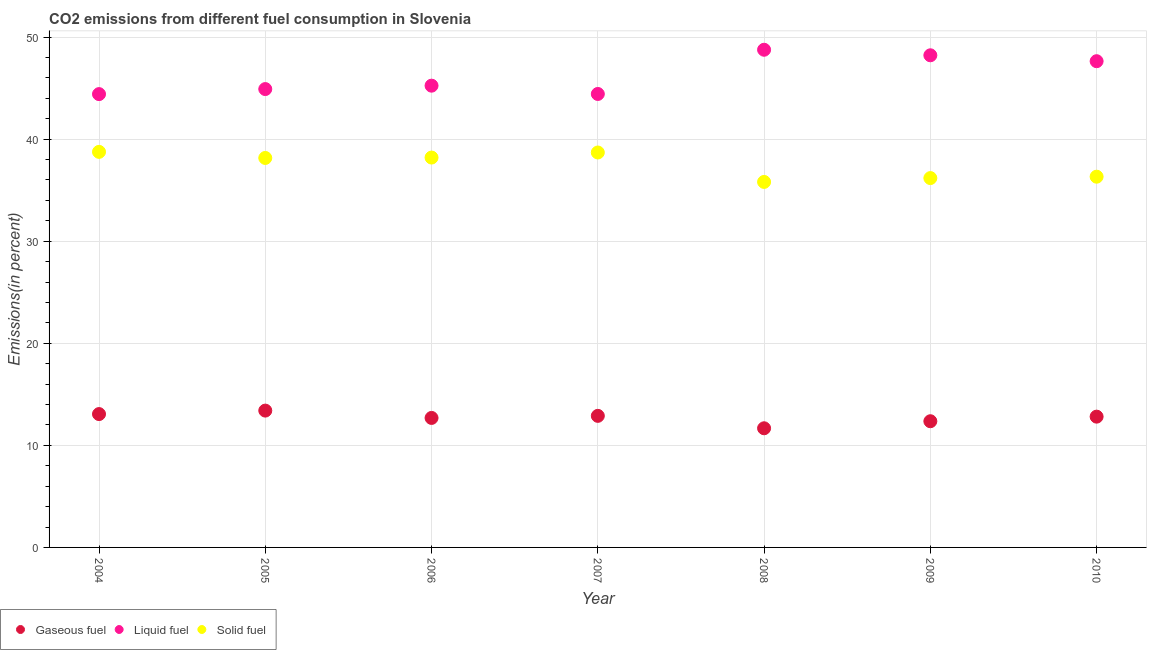How many different coloured dotlines are there?
Provide a short and direct response. 3. Is the number of dotlines equal to the number of legend labels?
Keep it short and to the point. Yes. What is the percentage of liquid fuel emission in 2010?
Offer a very short reply. 47.63. Across all years, what is the maximum percentage of solid fuel emission?
Give a very brief answer. 38.75. Across all years, what is the minimum percentage of solid fuel emission?
Make the answer very short. 35.81. What is the total percentage of gaseous fuel emission in the graph?
Keep it short and to the point. 88.89. What is the difference between the percentage of liquid fuel emission in 2006 and that in 2008?
Your answer should be very brief. -3.52. What is the difference between the percentage of liquid fuel emission in 2008 and the percentage of gaseous fuel emission in 2004?
Your answer should be very brief. 35.69. What is the average percentage of liquid fuel emission per year?
Ensure brevity in your answer.  46.23. In the year 2010, what is the difference between the percentage of solid fuel emission and percentage of gaseous fuel emission?
Ensure brevity in your answer.  23.51. What is the ratio of the percentage of gaseous fuel emission in 2009 to that in 2010?
Provide a short and direct response. 0.96. What is the difference between the highest and the second highest percentage of liquid fuel emission?
Offer a terse response. 0.54. What is the difference between the highest and the lowest percentage of solid fuel emission?
Your answer should be compact. 2.94. In how many years, is the percentage of solid fuel emission greater than the average percentage of solid fuel emission taken over all years?
Provide a short and direct response. 4. Is it the case that in every year, the sum of the percentage of gaseous fuel emission and percentage of liquid fuel emission is greater than the percentage of solid fuel emission?
Give a very brief answer. Yes. Is the percentage of liquid fuel emission strictly greater than the percentage of solid fuel emission over the years?
Your answer should be very brief. Yes. How many years are there in the graph?
Provide a succinct answer. 7. Are the values on the major ticks of Y-axis written in scientific E-notation?
Your answer should be very brief. No. Does the graph contain any zero values?
Provide a short and direct response. No. Where does the legend appear in the graph?
Ensure brevity in your answer.  Bottom left. How are the legend labels stacked?
Your answer should be compact. Horizontal. What is the title of the graph?
Provide a short and direct response. CO2 emissions from different fuel consumption in Slovenia. What is the label or title of the Y-axis?
Provide a succinct answer. Emissions(in percent). What is the Emissions(in percent) of Gaseous fuel in 2004?
Give a very brief answer. 13.06. What is the Emissions(in percent) of Liquid fuel in 2004?
Give a very brief answer. 44.41. What is the Emissions(in percent) in Solid fuel in 2004?
Your answer should be compact. 38.75. What is the Emissions(in percent) in Gaseous fuel in 2005?
Provide a short and direct response. 13.4. What is the Emissions(in percent) of Liquid fuel in 2005?
Offer a very short reply. 44.9. What is the Emissions(in percent) in Solid fuel in 2005?
Your response must be concise. 38.16. What is the Emissions(in percent) in Gaseous fuel in 2006?
Your response must be concise. 12.69. What is the Emissions(in percent) in Liquid fuel in 2006?
Keep it short and to the point. 45.24. What is the Emissions(in percent) of Solid fuel in 2006?
Your response must be concise. 38.19. What is the Emissions(in percent) in Gaseous fuel in 2007?
Keep it short and to the point. 12.89. What is the Emissions(in percent) in Liquid fuel in 2007?
Offer a very short reply. 44.42. What is the Emissions(in percent) of Solid fuel in 2007?
Your answer should be very brief. 38.69. What is the Emissions(in percent) in Gaseous fuel in 2008?
Your answer should be very brief. 11.67. What is the Emissions(in percent) in Liquid fuel in 2008?
Your response must be concise. 48.76. What is the Emissions(in percent) of Solid fuel in 2008?
Provide a succinct answer. 35.81. What is the Emissions(in percent) of Gaseous fuel in 2009?
Your response must be concise. 12.36. What is the Emissions(in percent) of Liquid fuel in 2009?
Make the answer very short. 48.21. What is the Emissions(in percent) of Solid fuel in 2009?
Your answer should be compact. 36.18. What is the Emissions(in percent) in Gaseous fuel in 2010?
Provide a succinct answer. 12.81. What is the Emissions(in percent) in Liquid fuel in 2010?
Offer a very short reply. 47.63. What is the Emissions(in percent) in Solid fuel in 2010?
Offer a very short reply. 36.32. Across all years, what is the maximum Emissions(in percent) of Gaseous fuel?
Give a very brief answer. 13.4. Across all years, what is the maximum Emissions(in percent) of Liquid fuel?
Offer a terse response. 48.76. Across all years, what is the maximum Emissions(in percent) in Solid fuel?
Your answer should be very brief. 38.75. Across all years, what is the minimum Emissions(in percent) in Gaseous fuel?
Give a very brief answer. 11.67. Across all years, what is the minimum Emissions(in percent) in Liquid fuel?
Give a very brief answer. 44.41. Across all years, what is the minimum Emissions(in percent) in Solid fuel?
Provide a short and direct response. 35.81. What is the total Emissions(in percent) of Gaseous fuel in the graph?
Your response must be concise. 88.89. What is the total Emissions(in percent) of Liquid fuel in the graph?
Your answer should be compact. 323.58. What is the total Emissions(in percent) in Solid fuel in the graph?
Keep it short and to the point. 262.1. What is the difference between the Emissions(in percent) of Gaseous fuel in 2004 and that in 2005?
Provide a short and direct response. -0.34. What is the difference between the Emissions(in percent) of Liquid fuel in 2004 and that in 2005?
Ensure brevity in your answer.  -0.49. What is the difference between the Emissions(in percent) in Solid fuel in 2004 and that in 2005?
Your answer should be compact. 0.6. What is the difference between the Emissions(in percent) in Gaseous fuel in 2004 and that in 2006?
Provide a succinct answer. 0.38. What is the difference between the Emissions(in percent) of Liquid fuel in 2004 and that in 2006?
Your answer should be compact. -0.83. What is the difference between the Emissions(in percent) in Solid fuel in 2004 and that in 2006?
Your answer should be compact. 0.56. What is the difference between the Emissions(in percent) in Gaseous fuel in 2004 and that in 2007?
Give a very brief answer. 0.18. What is the difference between the Emissions(in percent) of Liquid fuel in 2004 and that in 2007?
Provide a short and direct response. -0.01. What is the difference between the Emissions(in percent) of Solid fuel in 2004 and that in 2007?
Give a very brief answer. 0.06. What is the difference between the Emissions(in percent) of Gaseous fuel in 2004 and that in 2008?
Keep it short and to the point. 1.39. What is the difference between the Emissions(in percent) in Liquid fuel in 2004 and that in 2008?
Your response must be concise. -4.35. What is the difference between the Emissions(in percent) of Solid fuel in 2004 and that in 2008?
Your answer should be very brief. 2.94. What is the difference between the Emissions(in percent) in Gaseous fuel in 2004 and that in 2009?
Keep it short and to the point. 0.7. What is the difference between the Emissions(in percent) in Liquid fuel in 2004 and that in 2009?
Provide a succinct answer. -3.8. What is the difference between the Emissions(in percent) in Solid fuel in 2004 and that in 2009?
Give a very brief answer. 2.57. What is the difference between the Emissions(in percent) in Gaseous fuel in 2004 and that in 2010?
Make the answer very short. 0.25. What is the difference between the Emissions(in percent) of Liquid fuel in 2004 and that in 2010?
Your response must be concise. -3.22. What is the difference between the Emissions(in percent) in Solid fuel in 2004 and that in 2010?
Your response must be concise. 2.43. What is the difference between the Emissions(in percent) in Gaseous fuel in 2005 and that in 2006?
Offer a very short reply. 0.72. What is the difference between the Emissions(in percent) in Liquid fuel in 2005 and that in 2006?
Your answer should be very brief. -0.33. What is the difference between the Emissions(in percent) in Solid fuel in 2005 and that in 2006?
Offer a terse response. -0.04. What is the difference between the Emissions(in percent) of Gaseous fuel in 2005 and that in 2007?
Your answer should be compact. 0.51. What is the difference between the Emissions(in percent) in Liquid fuel in 2005 and that in 2007?
Offer a very short reply. 0.48. What is the difference between the Emissions(in percent) of Solid fuel in 2005 and that in 2007?
Offer a very short reply. -0.54. What is the difference between the Emissions(in percent) of Gaseous fuel in 2005 and that in 2008?
Your answer should be very brief. 1.73. What is the difference between the Emissions(in percent) in Liquid fuel in 2005 and that in 2008?
Give a very brief answer. -3.85. What is the difference between the Emissions(in percent) in Solid fuel in 2005 and that in 2008?
Offer a very short reply. 2.35. What is the difference between the Emissions(in percent) of Gaseous fuel in 2005 and that in 2009?
Provide a short and direct response. 1.04. What is the difference between the Emissions(in percent) in Liquid fuel in 2005 and that in 2009?
Keep it short and to the point. -3.31. What is the difference between the Emissions(in percent) of Solid fuel in 2005 and that in 2009?
Your response must be concise. 1.97. What is the difference between the Emissions(in percent) of Gaseous fuel in 2005 and that in 2010?
Your response must be concise. 0.59. What is the difference between the Emissions(in percent) in Liquid fuel in 2005 and that in 2010?
Give a very brief answer. -2.73. What is the difference between the Emissions(in percent) in Solid fuel in 2005 and that in 2010?
Give a very brief answer. 1.84. What is the difference between the Emissions(in percent) in Gaseous fuel in 2006 and that in 2007?
Your answer should be compact. -0.2. What is the difference between the Emissions(in percent) in Liquid fuel in 2006 and that in 2007?
Provide a succinct answer. 0.81. What is the difference between the Emissions(in percent) in Solid fuel in 2006 and that in 2007?
Provide a succinct answer. -0.5. What is the difference between the Emissions(in percent) in Gaseous fuel in 2006 and that in 2008?
Provide a short and direct response. 1.01. What is the difference between the Emissions(in percent) of Liquid fuel in 2006 and that in 2008?
Ensure brevity in your answer.  -3.52. What is the difference between the Emissions(in percent) of Solid fuel in 2006 and that in 2008?
Keep it short and to the point. 2.39. What is the difference between the Emissions(in percent) of Gaseous fuel in 2006 and that in 2009?
Give a very brief answer. 0.32. What is the difference between the Emissions(in percent) of Liquid fuel in 2006 and that in 2009?
Provide a short and direct response. -2.98. What is the difference between the Emissions(in percent) in Solid fuel in 2006 and that in 2009?
Offer a very short reply. 2.01. What is the difference between the Emissions(in percent) in Gaseous fuel in 2006 and that in 2010?
Offer a terse response. -0.13. What is the difference between the Emissions(in percent) in Liquid fuel in 2006 and that in 2010?
Give a very brief answer. -2.4. What is the difference between the Emissions(in percent) of Solid fuel in 2006 and that in 2010?
Keep it short and to the point. 1.87. What is the difference between the Emissions(in percent) of Gaseous fuel in 2007 and that in 2008?
Your response must be concise. 1.22. What is the difference between the Emissions(in percent) in Liquid fuel in 2007 and that in 2008?
Your answer should be very brief. -4.33. What is the difference between the Emissions(in percent) in Solid fuel in 2007 and that in 2008?
Offer a very short reply. 2.88. What is the difference between the Emissions(in percent) in Gaseous fuel in 2007 and that in 2009?
Provide a short and direct response. 0.53. What is the difference between the Emissions(in percent) of Liquid fuel in 2007 and that in 2009?
Offer a terse response. -3.79. What is the difference between the Emissions(in percent) in Solid fuel in 2007 and that in 2009?
Give a very brief answer. 2.51. What is the difference between the Emissions(in percent) of Gaseous fuel in 2007 and that in 2010?
Offer a terse response. 0.08. What is the difference between the Emissions(in percent) of Liquid fuel in 2007 and that in 2010?
Your response must be concise. -3.21. What is the difference between the Emissions(in percent) of Solid fuel in 2007 and that in 2010?
Ensure brevity in your answer.  2.37. What is the difference between the Emissions(in percent) of Gaseous fuel in 2008 and that in 2009?
Offer a terse response. -0.69. What is the difference between the Emissions(in percent) of Liquid fuel in 2008 and that in 2009?
Your answer should be compact. 0.54. What is the difference between the Emissions(in percent) of Solid fuel in 2008 and that in 2009?
Provide a succinct answer. -0.38. What is the difference between the Emissions(in percent) in Gaseous fuel in 2008 and that in 2010?
Your answer should be very brief. -1.14. What is the difference between the Emissions(in percent) in Liquid fuel in 2008 and that in 2010?
Your response must be concise. 1.12. What is the difference between the Emissions(in percent) of Solid fuel in 2008 and that in 2010?
Provide a short and direct response. -0.51. What is the difference between the Emissions(in percent) of Gaseous fuel in 2009 and that in 2010?
Your response must be concise. -0.45. What is the difference between the Emissions(in percent) in Liquid fuel in 2009 and that in 2010?
Provide a short and direct response. 0.58. What is the difference between the Emissions(in percent) in Solid fuel in 2009 and that in 2010?
Make the answer very short. -0.14. What is the difference between the Emissions(in percent) in Gaseous fuel in 2004 and the Emissions(in percent) in Liquid fuel in 2005?
Keep it short and to the point. -31.84. What is the difference between the Emissions(in percent) in Gaseous fuel in 2004 and the Emissions(in percent) in Solid fuel in 2005?
Provide a succinct answer. -25.09. What is the difference between the Emissions(in percent) in Liquid fuel in 2004 and the Emissions(in percent) in Solid fuel in 2005?
Your answer should be compact. 6.25. What is the difference between the Emissions(in percent) in Gaseous fuel in 2004 and the Emissions(in percent) in Liquid fuel in 2006?
Your answer should be compact. -32.17. What is the difference between the Emissions(in percent) of Gaseous fuel in 2004 and the Emissions(in percent) of Solid fuel in 2006?
Your answer should be compact. -25.13. What is the difference between the Emissions(in percent) of Liquid fuel in 2004 and the Emissions(in percent) of Solid fuel in 2006?
Your answer should be very brief. 6.22. What is the difference between the Emissions(in percent) of Gaseous fuel in 2004 and the Emissions(in percent) of Liquid fuel in 2007?
Your answer should be very brief. -31.36. What is the difference between the Emissions(in percent) in Gaseous fuel in 2004 and the Emissions(in percent) in Solid fuel in 2007?
Give a very brief answer. -25.63. What is the difference between the Emissions(in percent) of Liquid fuel in 2004 and the Emissions(in percent) of Solid fuel in 2007?
Ensure brevity in your answer.  5.72. What is the difference between the Emissions(in percent) in Gaseous fuel in 2004 and the Emissions(in percent) in Liquid fuel in 2008?
Give a very brief answer. -35.69. What is the difference between the Emissions(in percent) in Gaseous fuel in 2004 and the Emissions(in percent) in Solid fuel in 2008?
Provide a short and direct response. -22.74. What is the difference between the Emissions(in percent) of Liquid fuel in 2004 and the Emissions(in percent) of Solid fuel in 2008?
Keep it short and to the point. 8.6. What is the difference between the Emissions(in percent) in Gaseous fuel in 2004 and the Emissions(in percent) in Liquid fuel in 2009?
Offer a very short reply. -35.15. What is the difference between the Emissions(in percent) of Gaseous fuel in 2004 and the Emissions(in percent) of Solid fuel in 2009?
Ensure brevity in your answer.  -23.12. What is the difference between the Emissions(in percent) in Liquid fuel in 2004 and the Emissions(in percent) in Solid fuel in 2009?
Provide a succinct answer. 8.23. What is the difference between the Emissions(in percent) in Gaseous fuel in 2004 and the Emissions(in percent) in Liquid fuel in 2010?
Your answer should be very brief. -34.57. What is the difference between the Emissions(in percent) in Gaseous fuel in 2004 and the Emissions(in percent) in Solid fuel in 2010?
Make the answer very short. -23.26. What is the difference between the Emissions(in percent) in Liquid fuel in 2004 and the Emissions(in percent) in Solid fuel in 2010?
Provide a short and direct response. 8.09. What is the difference between the Emissions(in percent) of Gaseous fuel in 2005 and the Emissions(in percent) of Liquid fuel in 2006?
Keep it short and to the point. -31.83. What is the difference between the Emissions(in percent) in Gaseous fuel in 2005 and the Emissions(in percent) in Solid fuel in 2006?
Ensure brevity in your answer.  -24.79. What is the difference between the Emissions(in percent) of Liquid fuel in 2005 and the Emissions(in percent) of Solid fuel in 2006?
Make the answer very short. 6.71. What is the difference between the Emissions(in percent) in Gaseous fuel in 2005 and the Emissions(in percent) in Liquid fuel in 2007?
Give a very brief answer. -31.02. What is the difference between the Emissions(in percent) of Gaseous fuel in 2005 and the Emissions(in percent) of Solid fuel in 2007?
Offer a terse response. -25.29. What is the difference between the Emissions(in percent) in Liquid fuel in 2005 and the Emissions(in percent) in Solid fuel in 2007?
Your answer should be very brief. 6.21. What is the difference between the Emissions(in percent) of Gaseous fuel in 2005 and the Emissions(in percent) of Liquid fuel in 2008?
Provide a short and direct response. -35.35. What is the difference between the Emissions(in percent) of Gaseous fuel in 2005 and the Emissions(in percent) of Solid fuel in 2008?
Provide a short and direct response. -22.4. What is the difference between the Emissions(in percent) of Liquid fuel in 2005 and the Emissions(in percent) of Solid fuel in 2008?
Ensure brevity in your answer.  9.1. What is the difference between the Emissions(in percent) in Gaseous fuel in 2005 and the Emissions(in percent) in Liquid fuel in 2009?
Ensure brevity in your answer.  -34.81. What is the difference between the Emissions(in percent) in Gaseous fuel in 2005 and the Emissions(in percent) in Solid fuel in 2009?
Provide a succinct answer. -22.78. What is the difference between the Emissions(in percent) of Liquid fuel in 2005 and the Emissions(in percent) of Solid fuel in 2009?
Your response must be concise. 8.72. What is the difference between the Emissions(in percent) in Gaseous fuel in 2005 and the Emissions(in percent) in Liquid fuel in 2010?
Give a very brief answer. -34.23. What is the difference between the Emissions(in percent) of Gaseous fuel in 2005 and the Emissions(in percent) of Solid fuel in 2010?
Keep it short and to the point. -22.92. What is the difference between the Emissions(in percent) of Liquid fuel in 2005 and the Emissions(in percent) of Solid fuel in 2010?
Ensure brevity in your answer.  8.58. What is the difference between the Emissions(in percent) of Gaseous fuel in 2006 and the Emissions(in percent) of Liquid fuel in 2007?
Your answer should be compact. -31.74. What is the difference between the Emissions(in percent) of Gaseous fuel in 2006 and the Emissions(in percent) of Solid fuel in 2007?
Your response must be concise. -26. What is the difference between the Emissions(in percent) in Liquid fuel in 2006 and the Emissions(in percent) in Solid fuel in 2007?
Your answer should be very brief. 6.55. What is the difference between the Emissions(in percent) of Gaseous fuel in 2006 and the Emissions(in percent) of Liquid fuel in 2008?
Make the answer very short. -36.07. What is the difference between the Emissions(in percent) in Gaseous fuel in 2006 and the Emissions(in percent) in Solid fuel in 2008?
Your response must be concise. -23.12. What is the difference between the Emissions(in percent) in Liquid fuel in 2006 and the Emissions(in percent) in Solid fuel in 2008?
Keep it short and to the point. 9.43. What is the difference between the Emissions(in percent) in Gaseous fuel in 2006 and the Emissions(in percent) in Liquid fuel in 2009?
Make the answer very short. -35.53. What is the difference between the Emissions(in percent) in Gaseous fuel in 2006 and the Emissions(in percent) in Solid fuel in 2009?
Keep it short and to the point. -23.5. What is the difference between the Emissions(in percent) in Liquid fuel in 2006 and the Emissions(in percent) in Solid fuel in 2009?
Ensure brevity in your answer.  9.05. What is the difference between the Emissions(in percent) in Gaseous fuel in 2006 and the Emissions(in percent) in Liquid fuel in 2010?
Provide a succinct answer. -34.95. What is the difference between the Emissions(in percent) in Gaseous fuel in 2006 and the Emissions(in percent) in Solid fuel in 2010?
Your answer should be compact. -23.63. What is the difference between the Emissions(in percent) of Liquid fuel in 2006 and the Emissions(in percent) of Solid fuel in 2010?
Your response must be concise. 8.92. What is the difference between the Emissions(in percent) of Gaseous fuel in 2007 and the Emissions(in percent) of Liquid fuel in 2008?
Provide a succinct answer. -35.87. What is the difference between the Emissions(in percent) of Gaseous fuel in 2007 and the Emissions(in percent) of Solid fuel in 2008?
Your response must be concise. -22.92. What is the difference between the Emissions(in percent) of Liquid fuel in 2007 and the Emissions(in percent) of Solid fuel in 2008?
Provide a succinct answer. 8.62. What is the difference between the Emissions(in percent) in Gaseous fuel in 2007 and the Emissions(in percent) in Liquid fuel in 2009?
Provide a short and direct response. -35.32. What is the difference between the Emissions(in percent) in Gaseous fuel in 2007 and the Emissions(in percent) in Solid fuel in 2009?
Give a very brief answer. -23.29. What is the difference between the Emissions(in percent) in Liquid fuel in 2007 and the Emissions(in percent) in Solid fuel in 2009?
Provide a succinct answer. 8.24. What is the difference between the Emissions(in percent) in Gaseous fuel in 2007 and the Emissions(in percent) in Liquid fuel in 2010?
Provide a succinct answer. -34.75. What is the difference between the Emissions(in percent) of Gaseous fuel in 2007 and the Emissions(in percent) of Solid fuel in 2010?
Provide a succinct answer. -23.43. What is the difference between the Emissions(in percent) of Liquid fuel in 2007 and the Emissions(in percent) of Solid fuel in 2010?
Your answer should be very brief. 8.1. What is the difference between the Emissions(in percent) of Gaseous fuel in 2008 and the Emissions(in percent) of Liquid fuel in 2009?
Give a very brief answer. -36.54. What is the difference between the Emissions(in percent) of Gaseous fuel in 2008 and the Emissions(in percent) of Solid fuel in 2009?
Provide a succinct answer. -24.51. What is the difference between the Emissions(in percent) in Liquid fuel in 2008 and the Emissions(in percent) in Solid fuel in 2009?
Your response must be concise. 12.57. What is the difference between the Emissions(in percent) in Gaseous fuel in 2008 and the Emissions(in percent) in Liquid fuel in 2010?
Your answer should be compact. -35.96. What is the difference between the Emissions(in percent) of Gaseous fuel in 2008 and the Emissions(in percent) of Solid fuel in 2010?
Your answer should be very brief. -24.65. What is the difference between the Emissions(in percent) in Liquid fuel in 2008 and the Emissions(in percent) in Solid fuel in 2010?
Provide a succinct answer. 12.44. What is the difference between the Emissions(in percent) of Gaseous fuel in 2009 and the Emissions(in percent) of Liquid fuel in 2010?
Make the answer very short. -35.27. What is the difference between the Emissions(in percent) of Gaseous fuel in 2009 and the Emissions(in percent) of Solid fuel in 2010?
Your response must be concise. -23.96. What is the difference between the Emissions(in percent) in Liquid fuel in 2009 and the Emissions(in percent) in Solid fuel in 2010?
Give a very brief answer. 11.89. What is the average Emissions(in percent) of Gaseous fuel per year?
Ensure brevity in your answer.  12.7. What is the average Emissions(in percent) in Liquid fuel per year?
Provide a succinct answer. 46.23. What is the average Emissions(in percent) in Solid fuel per year?
Ensure brevity in your answer.  37.44. In the year 2004, what is the difference between the Emissions(in percent) of Gaseous fuel and Emissions(in percent) of Liquid fuel?
Offer a terse response. -31.35. In the year 2004, what is the difference between the Emissions(in percent) in Gaseous fuel and Emissions(in percent) in Solid fuel?
Ensure brevity in your answer.  -25.69. In the year 2004, what is the difference between the Emissions(in percent) in Liquid fuel and Emissions(in percent) in Solid fuel?
Your answer should be very brief. 5.66. In the year 2005, what is the difference between the Emissions(in percent) of Gaseous fuel and Emissions(in percent) of Liquid fuel?
Offer a terse response. -31.5. In the year 2005, what is the difference between the Emissions(in percent) in Gaseous fuel and Emissions(in percent) in Solid fuel?
Your answer should be very brief. -24.75. In the year 2005, what is the difference between the Emissions(in percent) in Liquid fuel and Emissions(in percent) in Solid fuel?
Offer a terse response. 6.75. In the year 2006, what is the difference between the Emissions(in percent) in Gaseous fuel and Emissions(in percent) in Liquid fuel?
Offer a terse response. -32.55. In the year 2006, what is the difference between the Emissions(in percent) in Gaseous fuel and Emissions(in percent) in Solid fuel?
Offer a terse response. -25.51. In the year 2006, what is the difference between the Emissions(in percent) in Liquid fuel and Emissions(in percent) in Solid fuel?
Ensure brevity in your answer.  7.04. In the year 2007, what is the difference between the Emissions(in percent) of Gaseous fuel and Emissions(in percent) of Liquid fuel?
Ensure brevity in your answer.  -31.54. In the year 2007, what is the difference between the Emissions(in percent) of Gaseous fuel and Emissions(in percent) of Solid fuel?
Your response must be concise. -25.8. In the year 2007, what is the difference between the Emissions(in percent) in Liquid fuel and Emissions(in percent) in Solid fuel?
Keep it short and to the point. 5.73. In the year 2008, what is the difference between the Emissions(in percent) of Gaseous fuel and Emissions(in percent) of Liquid fuel?
Keep it short and to the point. -37.08. In the year 2008, what is the difference between the Emissions(in percent) in Gaseous fuel and Emissions(in percent) in Solid fuel?
Your answer should be very brief. -24.13. In the year 2008, what is the difference between the Emissions(in percent) in Liquid fuel and Emissions(in percent) in Solid fuel?
Keep it short and to the point. 12.95. In the year 2009, what is the difference between the Emissions(in percent) of Gaseous fuel and Emissions(in percent) of Liquid fuel?
Provide a short and direct response. -35.85. In the year 2009, what is the difference between the Emissions(in percent) of Gaseous fuel and Emissions(in percent) of Solid fuel?
Offer a very short reply. -23.82. In the year 2009, what is the difference between the Emissions(in percent) in Liquid fuel and Emissions(in percent) in Solid fuel?
Keep it short and to the point. 12.03. In the year 2010, what is the difference between the Emissions(in percent) in Gaseous fuel and Emissions(in percent) in Liquid fuel?
Offer a terse response. -34.82. In the year 2010, what is the difference between the Emissions(in percent) in Gaseous fuel and Emissions(in percent) in Solid fuel?
Provide a short and direct response. -23.51. In the year 2010, what is the difference between the Emissions(in percent) of Liquid fuel and Emissions(in percent) of Solid fuel?
Your response must be concise. 11.31. What is the ratio of the Emissions(in percent) in Gaseous fuel in 2004 to that in 2005?
Provide a succinct answer. 0.97. What is the ratio of the Emissions(in percent) of Liquid fuel in 2004 to that in 2005?
Your answer should be very brief. 0.99. What is the ratio of the Emissions(in percent) in Solid fuel in 2004 to that in 2005?
Keep it short and to the point. 1.02. What is the ratio of the Emissions(in percent) in Gaseous fuel in 2004 to that in 2006?
Provide a succinct answer. 1.03. What is the ratio of the Emissions(in percent) of Liquid fuel in 2004 to that in 2006?
Give a very brief answer. 0.98. What is the ratio of the Emissions(in percent) of Solid fuel in 2004 to that in 2006?
Provide a succinct answer. 1.01. What is the ratio of the Emissions(in percent) of Gaseous fuel in 2004 to that in 2007?
Your answer should be compact. 1.01. What is the ratio of the Emissions(in percent) of Liquid fuel in 2004 to that in 2007?
Offer a terse response. 1. What is the ratio of the Emissions(in percent) in Gaseous fuel in 2004 to that in 2008?
Your answer should be very brief. 1.12. What is the ratio of the Emissions(in percent) in Liquid fuel in 2004 to that in 2008?
Provide a succinct answer. 0.91. What is the ratio of the Emissions(in percent) of Solid fuel in 2004 to that in 2008?
Offer a very short reply. 1.08. What is the ratio of the Emissions(in percent) in Gaseous fuel in 2004 to that in 2009?
Keep it short and to the point. 1.06. What is the ratio of the Emissions(in percent) of Liquid fuel in 2004 to that in 2009?
Your answer should be very brief. 0.92. What is the ratio of the Emissions(in percent) of Solid fuel in 2004 to that in 2009?
Give a very brief answer. 1.07. What is the ratio of the Emissions(in percent) of Gaseous fuel in 2004 to that in 2010?
Keep it short and to the point. 1.02. What is the ratio of the Emissions(in percent) of Liquid fuel in 2004 to that in 2010?
Give a very brief answer. 0.93. What is the ratio of the Emissions(in percent) in Solid fuel in 2004 to that in 2010?
Your answer should be compact. 1.07. What is the ratio of the Emissions(in percent) in Gaseous fuel in 2005 to that in 2006?
Your response must be concise. 1.06. What is the ratio of the Emissions(in percent) of Solid fuel in 2005 to that in 2006?
Provide a short and direct response. 1. What is the ratio of the Emissions(in percent) in Gaseous fuel in 2005 to that in 2007?
Offer a terse response. 1.04. What is the ratio of the Emissions(in percent) in Liquid fuel in 2005 to that in 2007?
Give a very brief answer. 1.01. What is the ratio of the Emissions(in percent) in Solid fuel in 2005 to that in 2007?
Your answer should be compact. 0.99. What is the ratio of the Emissions(in percent) of Gaseous fuel in 2005 to that in 2008?
Offer a very short reply. 1.15. What is the ratio of the Emissions(in percent) in Liquid fuel in 2005 to that in 2008?
Provide a short and direct response. 0.92. What is the ratio of the Emissions(in percent) of Solid fuel in 2005 to that in 2008?
Your answer should be compact. 1.07. What is the ratio of the Emissions(in percent) of Gaseous fuel in 2005 to that in 2009?
Provide a short and direct response. 1.08. What is the ratio of the Emissions(in percent) in Liquid fuel in 2005 to that in 2009?
Ensure brevity in your answer.  0.93. What is the ratio of the Emissions(in percent) in Solid fuel in 2005 to that in 2009?
Ensure brevity in your answer.  1.05. What is the ratio of the Emissions(in percent) in Gaseous fuel in 2005 to that in 2010?
Give a very brief answer. 1.05. What is the ratio of the Emissions(in percent) of Liquid fuel in 2005 to that in 2010?
Your response must be concise. 0.94. What is the ratio of the Emissions(in percent) of Solid fuel in 2005 to that in 2010?
Provide a succinct answer. 1.05. What is the ratio of the Emissions(in percent) in Gaseous fuel in 2006 to that in 2007?
Offer a very short reply. 0.98. What is the ratio of the Emissions(in percent) in Liquid fuel in 2006 to that in 2007?
Your response must be concise. 1.02. What is the ratio of the Emissions(in percent) in Solid fuel in 2006 to that in 2007?
Provide a short and direct response. 0.99. What is the ratio of the Emissions(in percent) in Gaseous fuel in 2006 to that in 2008?
Ensure brevity in your answer.  1.09. What is the ratio of the Emissions(in percent) in Liquid fuel in 2006 to that in 2008?
Provide a short and direct response. 0.93. What is the ratio of the Emissions(in percent) of Solid fuel in 2006 to that in 2008?
Offer a very short reply. 1.07. What is the ratio of the Emissions(in percent) in Gaseous fuel in 2006 to that in 2009?
Keep it short and to the point. 1.03. What is the ratio of the Emissions(in percent) of Liquid fuel in 2006 to that in 2009?
Offer a very short reply. 0.94. What is the ratio of the Emissions(in percent) of Solid fuel in 2006 to that in 2009?
Your response must be concise. 1.06. What is the ratio of the Emissions(in percent) of Gaseous fuel in 2006 to that in 2010?
Give a very brief answer. 0.99. What is the ratio of the Emissions(in percent) of Liquid fuel in 2006 to that in 2010?
Your answer should be very brief. 0.95. What is the ratio of the Emissions(in percent) in Solid fuel in 2006 to that in 2010?
Keep it short and to the point. 1.05. What is the ratio of the Emissions(in percent) of Gaseous fuel in 2007 to that in 2008?
Offer a very short reply. 1.1. What is the ratio of the Emissions(in percent) in Liquid fuel in 2007 to that in 2008?
Your answer should be very brief. 0.91. What is the ratio of the Emissions(in percent) in Solid fuel in 2007 to that in 2008?
Keep it short and to the point. 1.08. What is the ratio of the Emissions(in percent) of Gaseous fuel in 2007 to that in 2009?
Make the answer very short. 1.04. What is the ratio of the Emissions(in percent) of Liquid fuel in 2007 to that in 2009?
Keep it short and to the point. 0.92. What is the ratio of the Emissions(in percent) of Solid fuel in 2007 to that in 2009?
Your answer should be compact. 1.07. What is the ratio of the Emissions(in percent) in Liquid fuel in 2007 to that in 2010?
Your response must be concise. 0.93. What is the ratio of the Emissions(in percent) in Solid fuel in 2007 to that in 2010?
Provide a short and direct response. 1.07. What is the ratio of the Emissions(in percent) in Gaseous fuel in 2008 to that in 2009?
Ensure brevity in your answer.  0.94. What is the ratio of the Emissions(in percent) of Liquid fuel in 2008 to that in 2009?
Give a very brief answer. 1.01. What is the ratio of the Emissions(in percent) in Gaseous fuel in 2008 to that in 2010?
Give a very brief answer. 0.91. What is the ratio of the Emissions(in percent) of Liquid fuel in 2008 to that in 2010?
Provide a short and direct response. 1.02. What is the ratio of the Emissions(in percent) of Solid fuel in 2008 to that in 2010?
Your response must be concise. 0.99. What is the ratio of the Emissions(in percent) of Liquid fuel in 2009 to that in 2010?
Your answer should be very brief. 1.01. What is the ratio of the Emissions(in percent) in Solid fuel in 2009 to that in 2010?
Keep it short and to the point. 1. What is the difference between the highest and the second highest Emissions(in percent) of Gaseous fuel?
Keep it short and to the point. 0.34. What is the difference between the highest and the second highest Emissions(in percent) of Liquid fuel?
Give a very brief answer. 0.54. What is the difference between the highest and the second highest Emissions(in percent) in Solid fuel?
Offer a very short reply. 0.06. What is the difference between the highest and the lowest Emissions(in percent) in Gaseous fuel?
Keep it short and to the point. 1.73. What is the difference between the highest and the lowest Emissions(in percent) in Liquid fuel?
Your answer should be compact. 4.35. What is the difference between the highest and the lowest Emissions(in percent) in Solid fuel?
Provide a short and direct response. 2.94. 